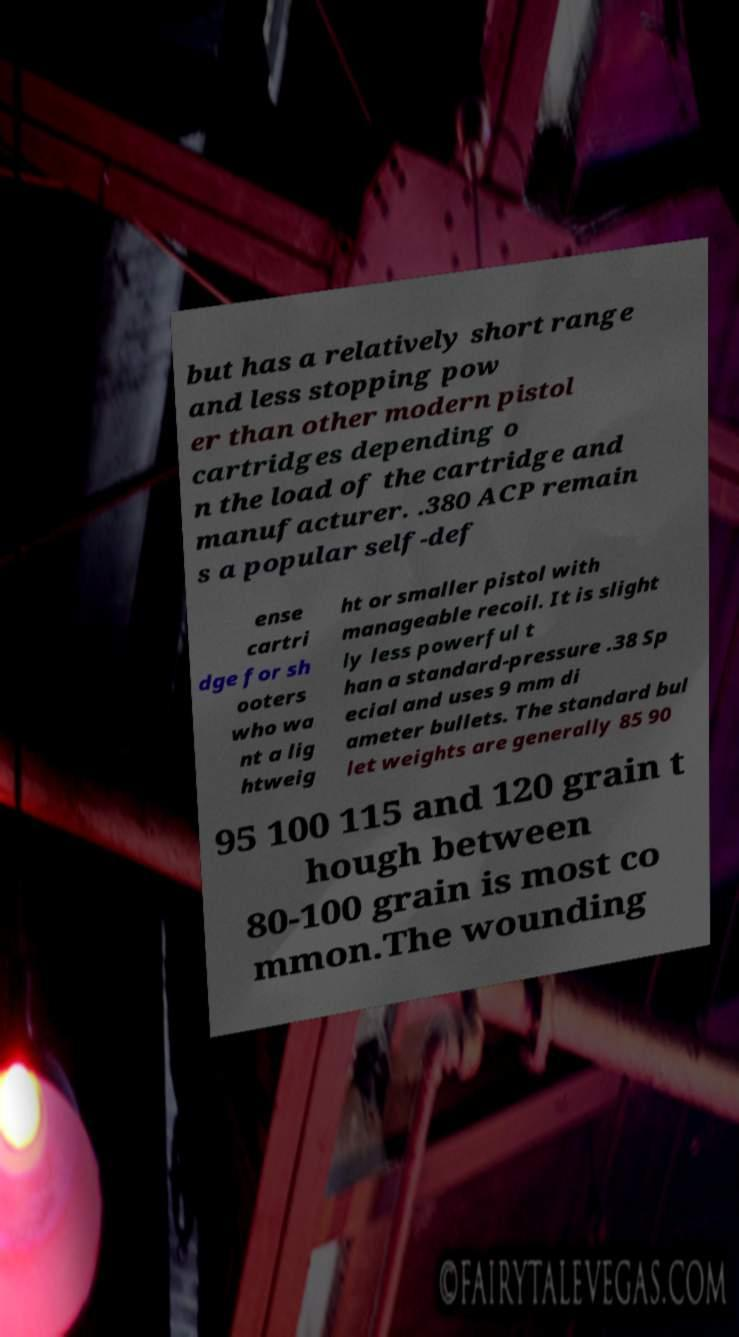For documentation purposes, I need the text within this image transcribed. Could you provide that? but has a relatively short range and less stopping pow er than other modern pistol cartridges depending o n the load of the cartridge and manufacturer. .380 ACP remain s a popular self-def ense cartri dge for sh ooters who wa nt a lig htweig ht or smaller pistol with manageable recoil. It is slight ly less powerful t han a standard-pressure .38 Sp ecial and uses 9 mm di ameter bullets. The standard bul let weights are generally 85 90 95 100 115 and 120 grain t hough between 80-100 grain is most co mmon.The wounding 